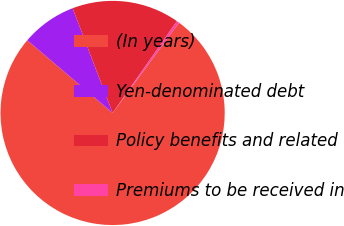Convert chart to OTSL. <chart><loc_0><loc_0><loc_500><loc_500><pie_chart><fcel>(In years)<fcel>Yen-denominated debt<fcel>Policy benefits and related<fcel>Premiums to be received in<nl><fcel>76.13%<fcel>7.96%<fcel>15.53%<fcel>0.38%<nl></chart> 